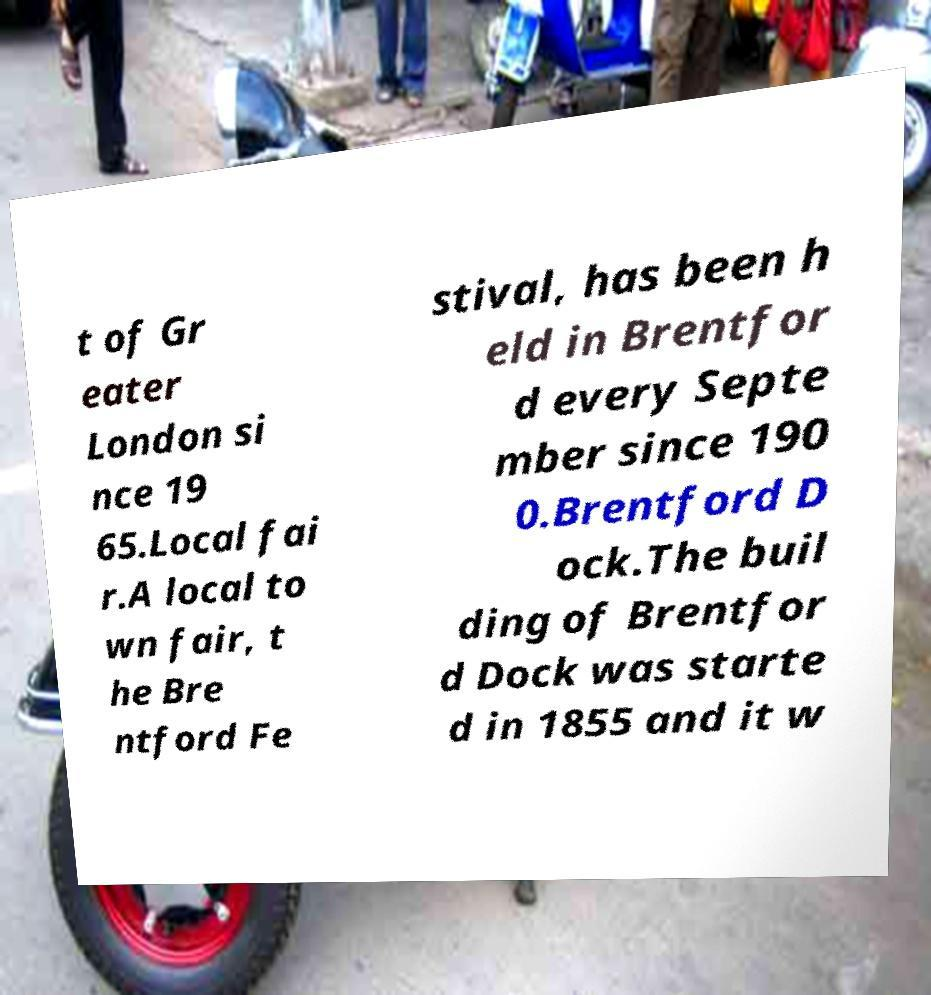For documentation purposes, I need the text within this image transcribed. Could you provide that? t of Gr eater London si nce 19 65.Local fai r.A local to wn fair, t he Bre ntford Fe stival, has been h eld in Brentfor d every Septe mber since 190 0.Brentford D ock.The buil ding of Brentfor d Dock was starte d in 1855 and it w 